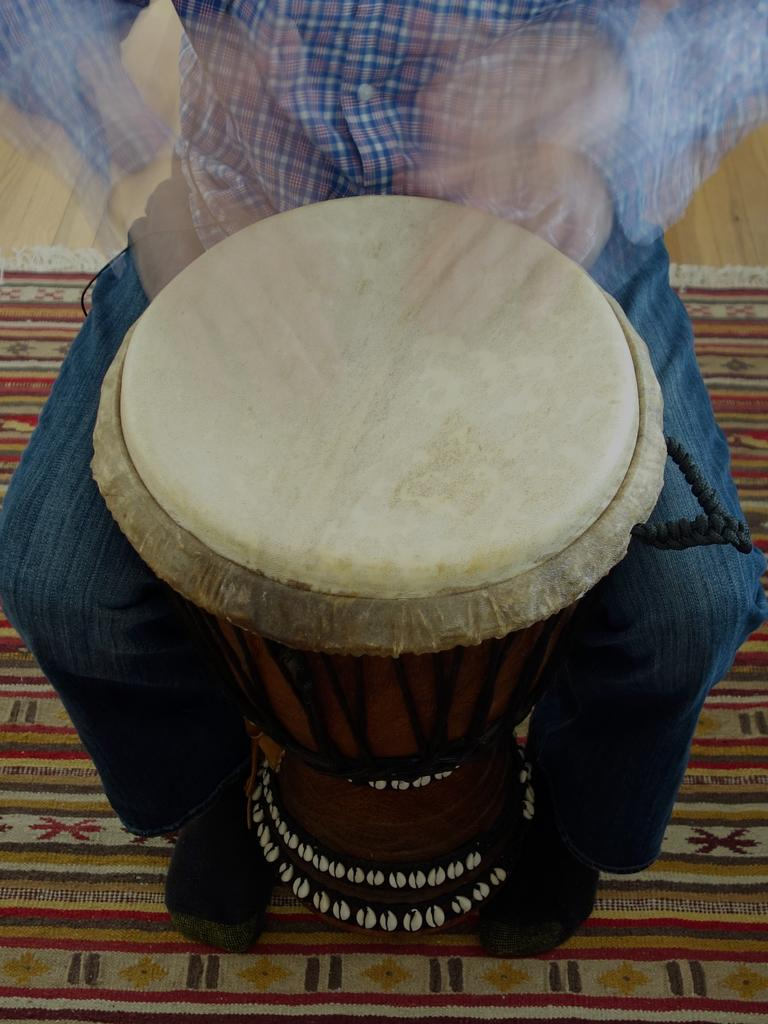What can be seen in the image? There is a person in the image. What is the person wearing? The person is wearing blue jeans. What else is present in the image? There is a musical instrument in the image. How does the person's feeling affect the musical instrument in the image? There is no information about the person's feelings in the image, so it cannot be determined how their feelings might affect the musical instrument. 